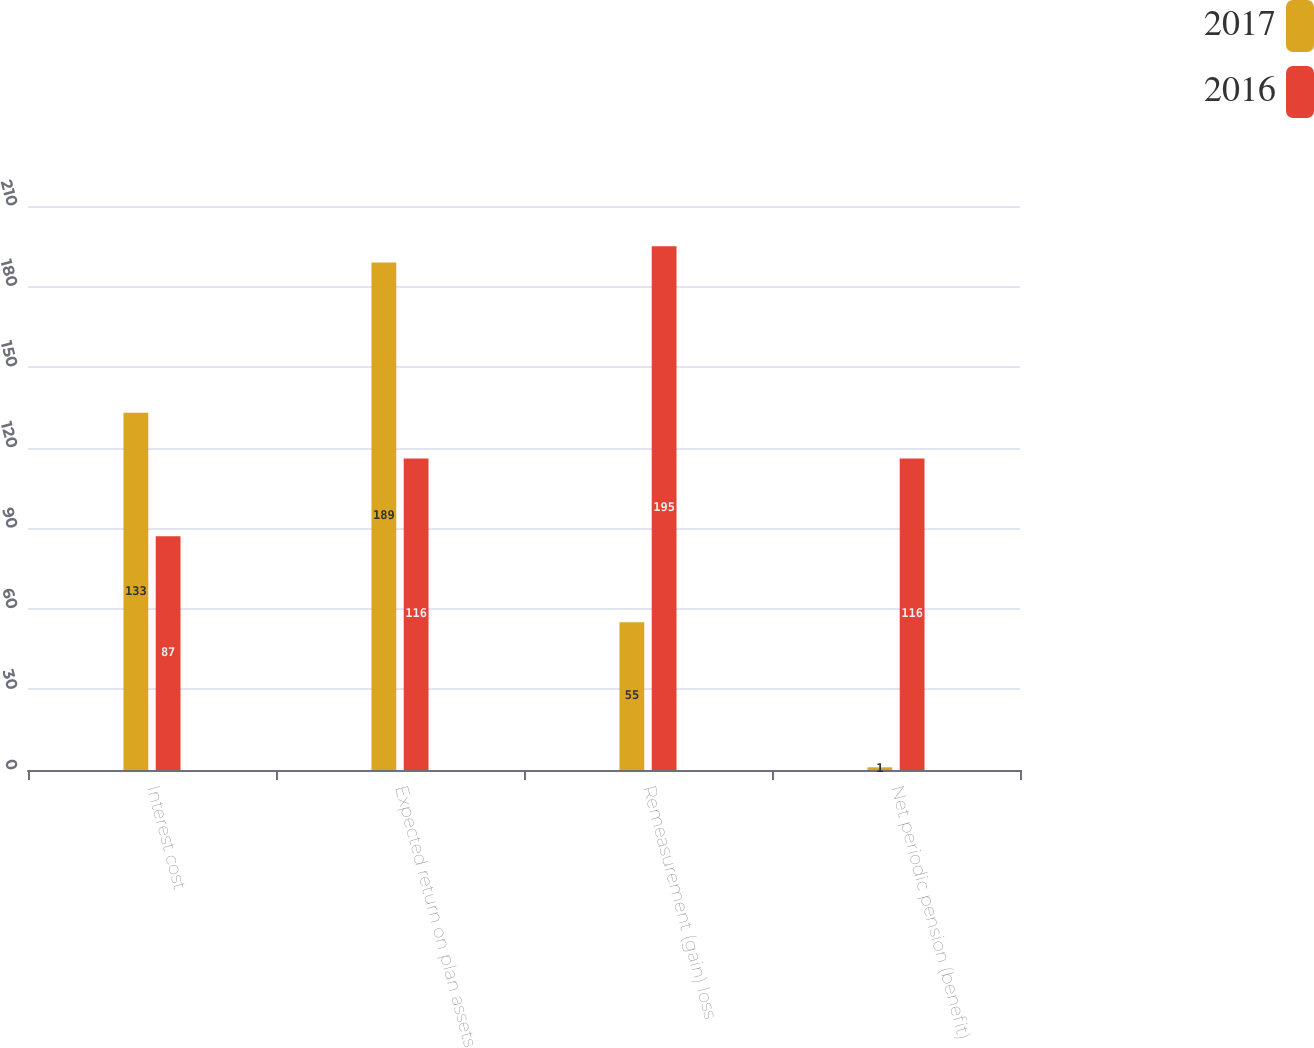Convert chart to OTSL. <chart><loc_0><loc_0><loc_500><loc_500><stacked_bar_chart><ecel><fcel>Interest cost<fcel>Expected return on plan assets<fcel>Remeasurement (gain) loss<fcel>Net periodic pension (benefit)<nl><fcel>2017<fcel>133<fcel>189<fcel>55<fcel>1<nl><fcel>2016<fcel>87<fcel>116<fcel>195<fcel>116<nl></chart> 